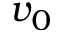<formula> <loc_0><loc_0><loc_500><loc_500>v _ { 0 }</formula> 